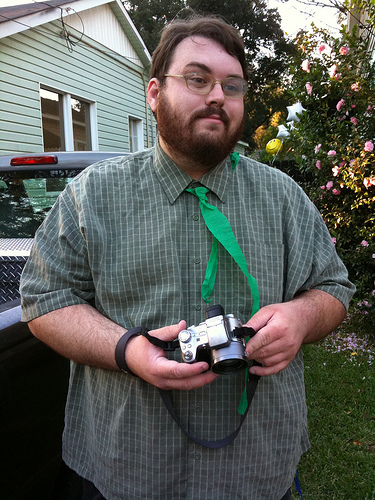What is the device that is to the right of the vehicle that is on the left of the photo? The device to the right of the vehicle on the left side of the photo is a film camera, characterized by its vintage design. 